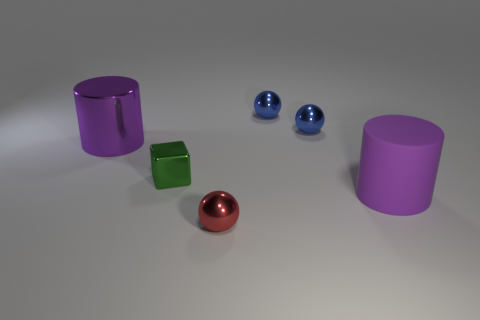There is a cylinder to the left of the red sphere; is it the same color as the cylinder that is right of the green object?
Give a very brief answer. Yes. Are there fewer purple metallic things that are in front of the small green object than purple metallic cylinders behind the large purple shiny cylinder?
Give a very brief answer. No. Is there anything else that has the same shape as the big rubber thing?
Your answer should be very brief. Yes. What color is the other big object that is the same shape as the large purple rubber object?
Give a very brief answer. Purple. Is the shape of the red shiny object the same as the large thing on the right side of the large purple metal object?
Keep it short and to the point. No. What number of objects are either balls that are behind the rubber thing or purple objects on the right side of the metallic cylinder?
Make the answer very short. 3. What material is the small green block?
Your answer should be compact. Metal. How many other objects are there of the same size as the red metallic sphere?
Your answer should be very brief. 3. There is a purple cylinder that is on the right side of the big purple metallic cylinder; what is its size?
Offer a very short reply. Large. There is a big cylinder that is right of the large cylinder on the left side of the big cylinder to the right of the metal cylinder; what is it made of?
Ensure brevity in your answer.  Rubber. 